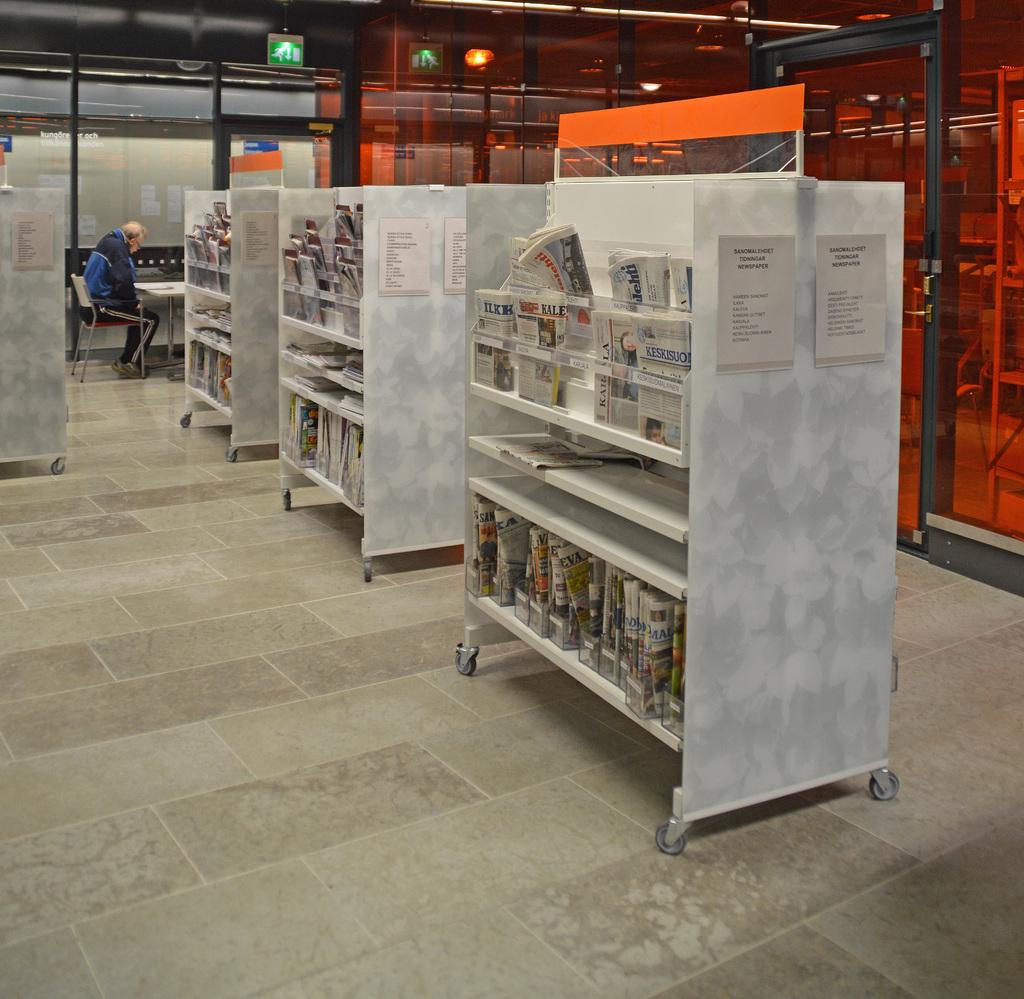<image>
Write a terse but informative summary of the picture. Shelves of newspapers in a foreign language in front of a sitting man. 